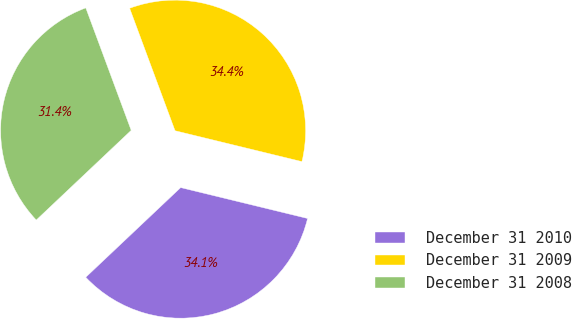Convert chart. <chart><loc_0><loc_0><loc_500><loc_500><pie_chart><fcel>December 31 2010<fcel>December 31 2009<fcel>December 31 2008<nl><fcel>34.15%<fcel>34.45%<fcel>31.4%<nl></chart> 